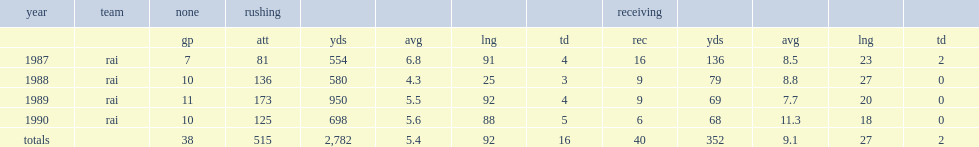How many yards did bo jackson catch in total? 352.0. 